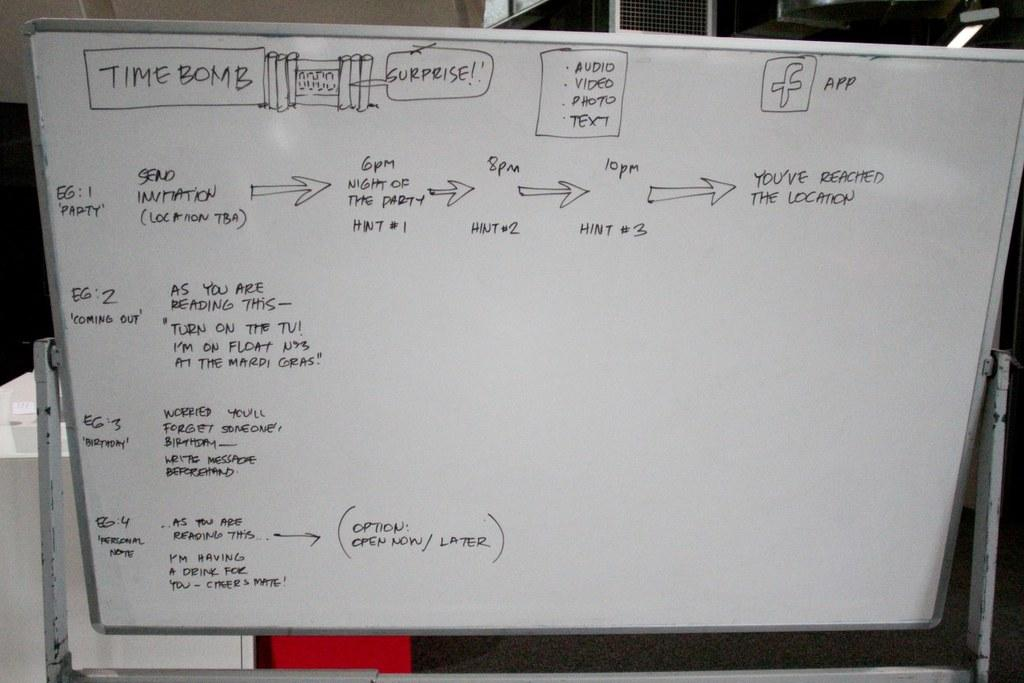<image>
Offer a succinct explanation of the picture presented. A white board has a box drawn at the top saying time bomb. 